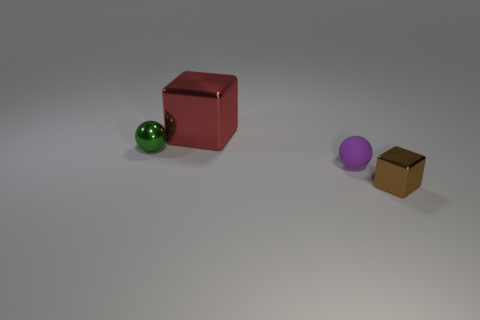Subtract 1 cubes. How many cubes are left? 1 Add 4 small balls. How many objects exist? 8 Subtract all purple spheres. How many spheres are left? 1 Add 1 small matte spheres. How many small matte spheres exist? 2 Subtract 0 red cylinders. How many objects are left? 4 Subtract all red spheres. Subtract all cyan blocks. How many spheres are left? 2 Subtract all green balls. How many red cubes are left? 1 Subtract all metallic objects. Subtract all large brown balls. How many objects are left? 1 Add 3 red metallic objects. How many red metallic objects are left? 4 